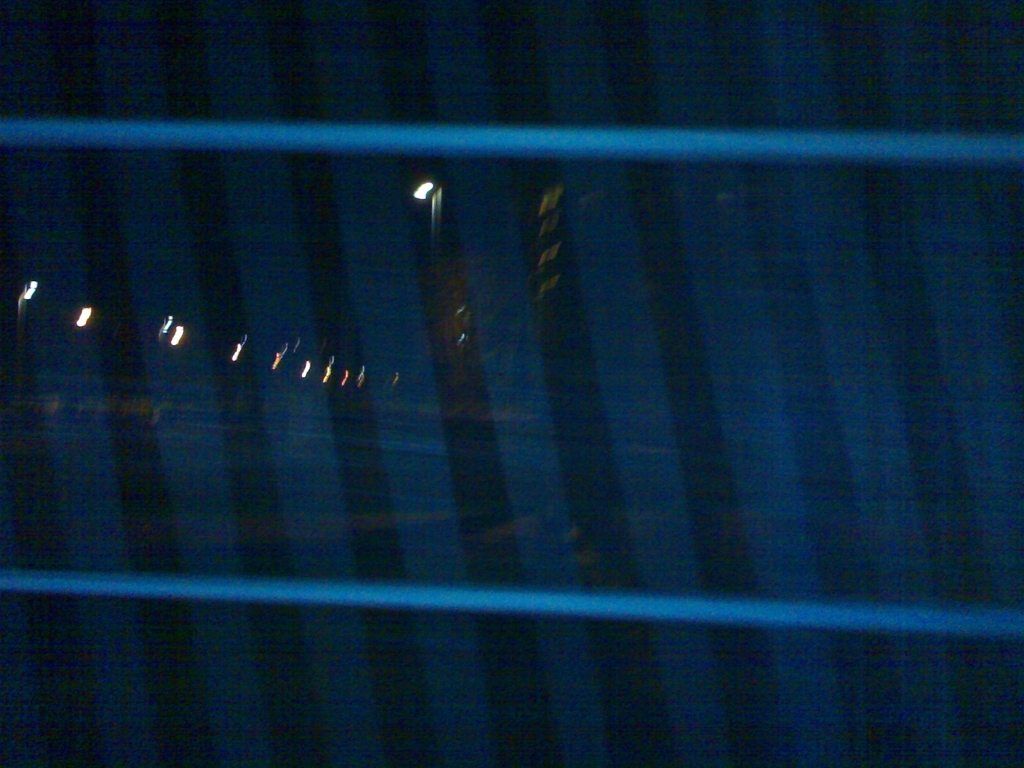What could be improved in this photograph to enhance its visual appeal? Improving this photograph could involve several techniques: increasing the exposure to reveal more details in the shadows, stabilizing the camera to prevent motion blur, and considering a different composition to create a focal point. Experimenting with different angles or perspectives could also provide depth and interest, and employing the rule of thirds might contribute to a more engaging composition. 